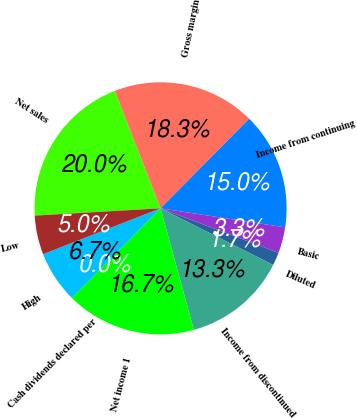Convert chart to OTSL. <chart><loc_0><loc_0><loc_500><loc_500><pie_chart><fcel>Net sales<fcel>Gross margin<fcel>Income from continuing<fcel>Basic<fcel>Diluted<fcel>Income from discontinued<fcel>Net income 1<fcel>Cash dividends declared per<fcel>High<fcel>Low<nl><fcel>20.0%<fcel>18.33%<fcel>15.0%<fcel>3.33%<fcel>1.67%<fcel>13.33%<fcel>16.67%<fcel>0.0%<fcel>6.67%<fcel>5.0%<nl></chart> 